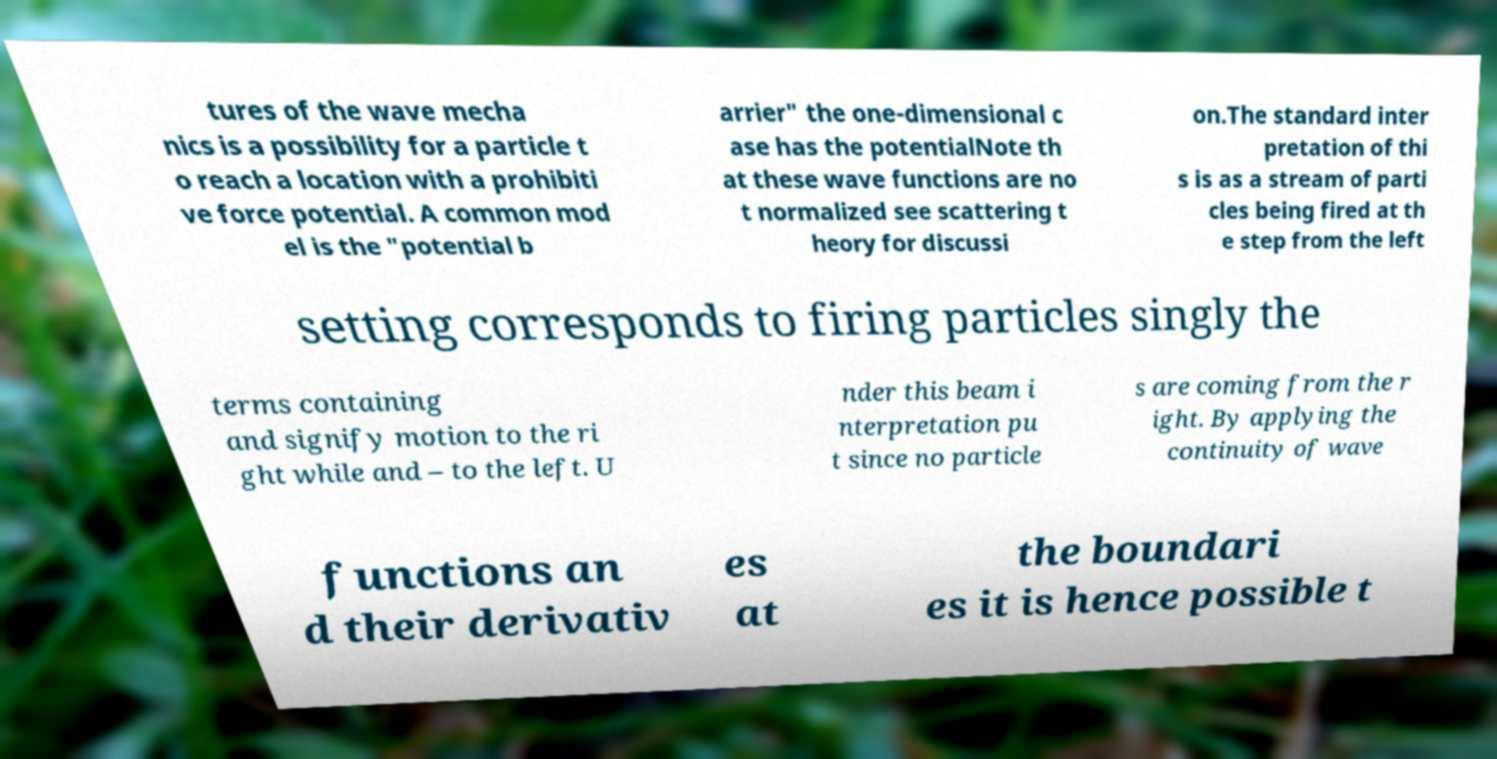For documentation purposes, I need the text within this image transcribed. Could you provide that? tures of the wave mecha nics is a possibility for a particle t o reach a location with a prohibiti ve force potential. A common mod el is the "potential b arrier" the one-dimensional c ase has the potentialNote th at these wave functions are no t normalized see scattering t heory for discussi on.The standard inter pretation of thi s is as a stream of parti cles being fired at th e step from the left setting corresponds to firing particles singly the terms containing and signify motion to the ri ght while and – to the left. U nder this beam i nterpretation pu t since no particle s are coming from the r ight. By applying the continuity of wave functions an d their derivativ es at the boundari es it is hence possible t 